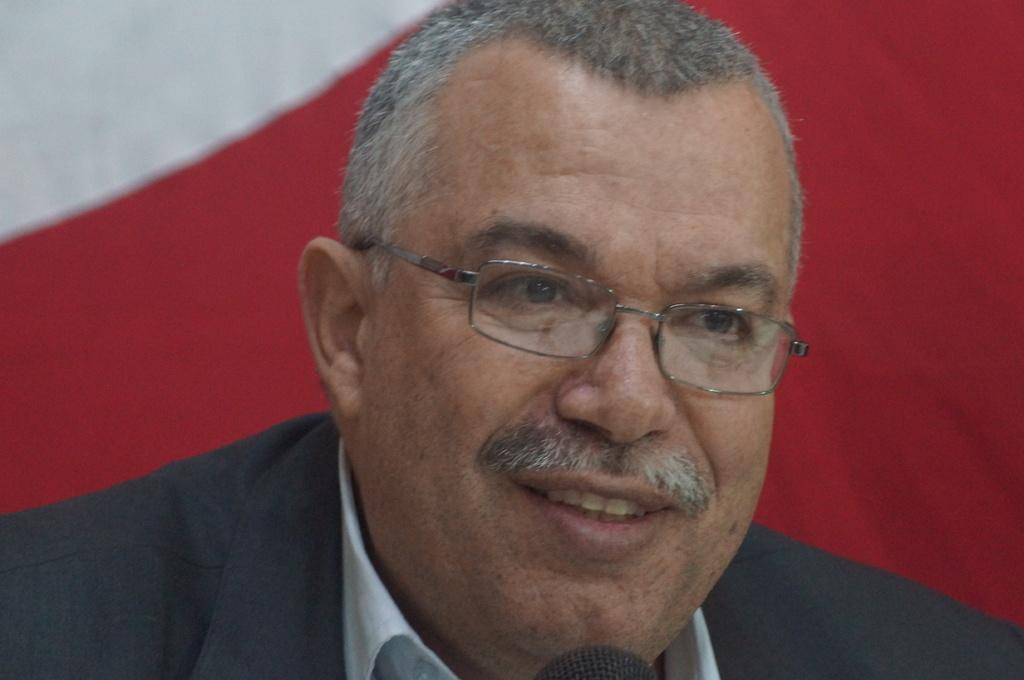Who is present in the image? There is a man in the image. What accessory is the man wearing? The man is wearing glasses. What can be seen in the background of the image? There is cloth visible in the background of the image. What object is located at the bottom of the image? There is a mic at the bottom of the image. What type of dogs can be seen in the image? There are no dogs present in the image. What is the purpose of the image? The purpose of the image cannot be determined from the image itself. What discovery was made during the event depicted in the image? There is no event or discovery depicted in the image. 